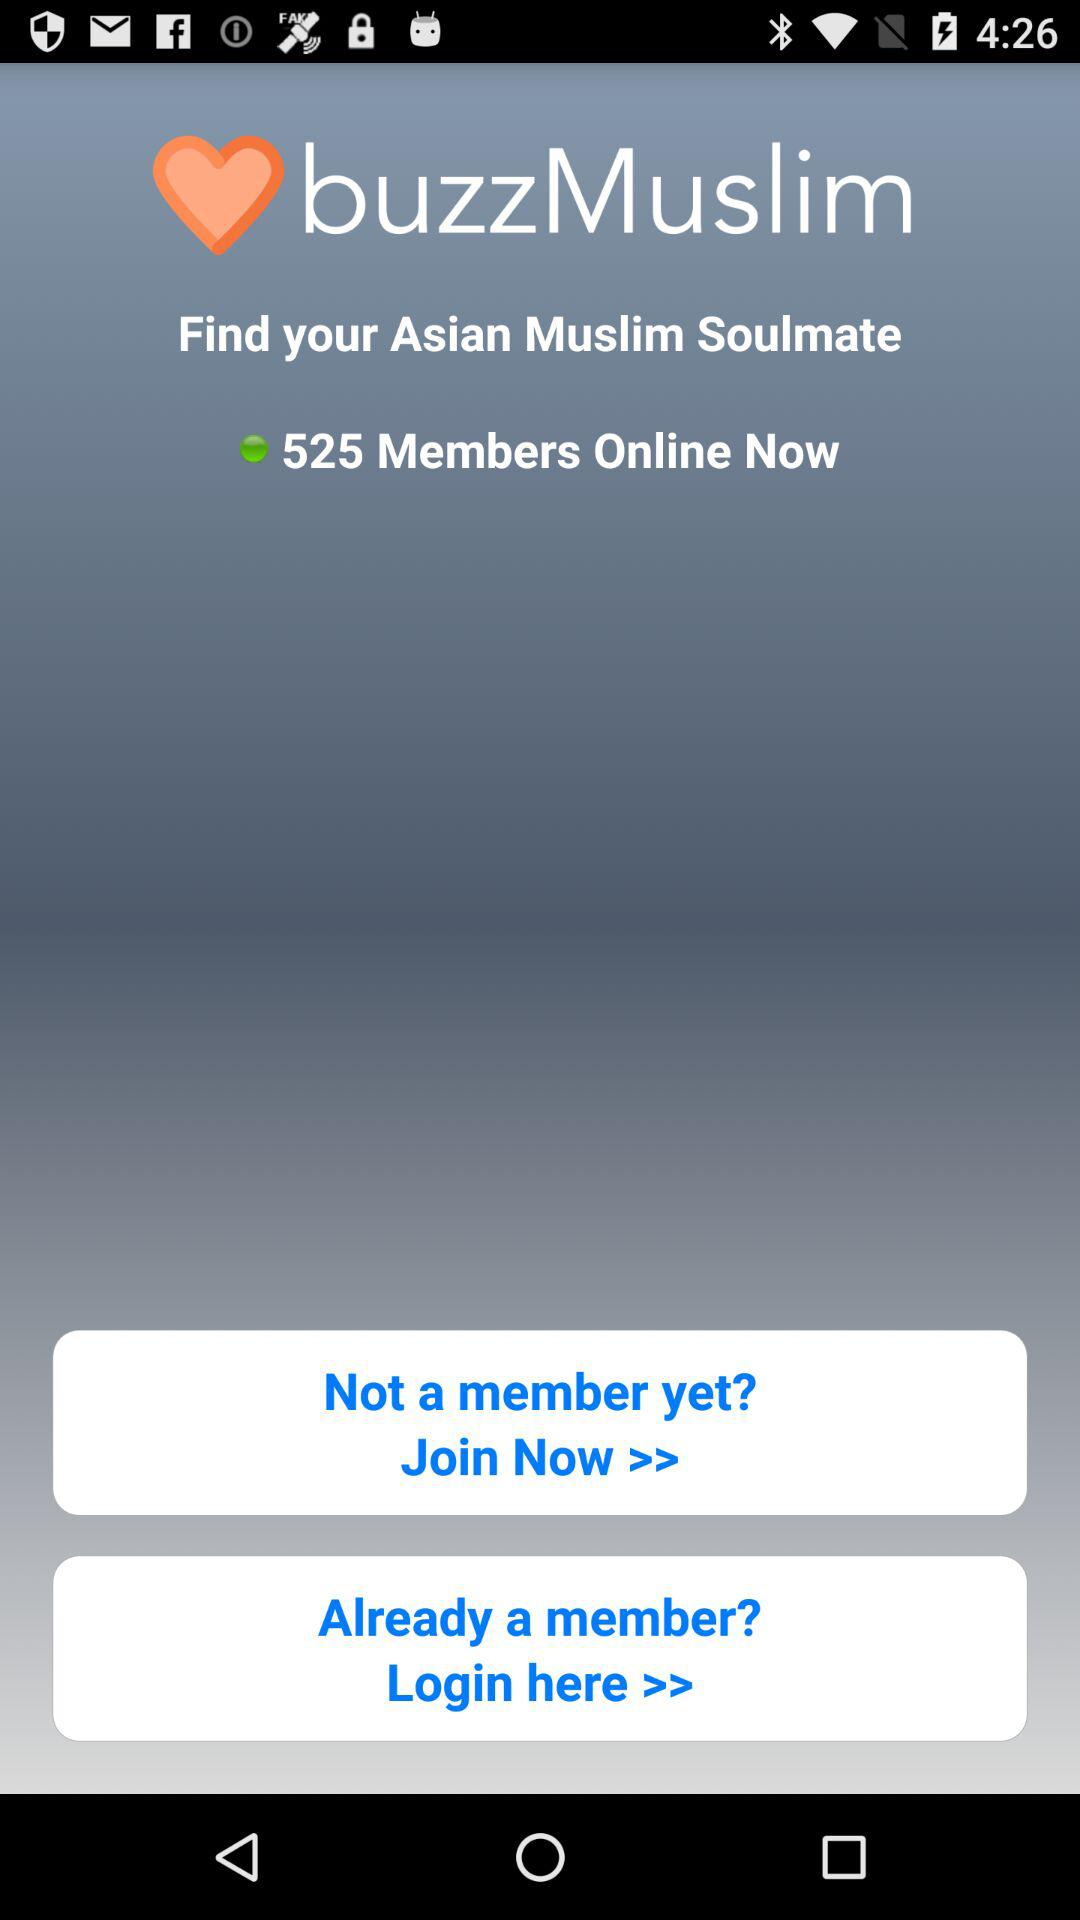What are the requirements to log in?
When the provided information is insufficient, respond with <no answer>. <no answer> 